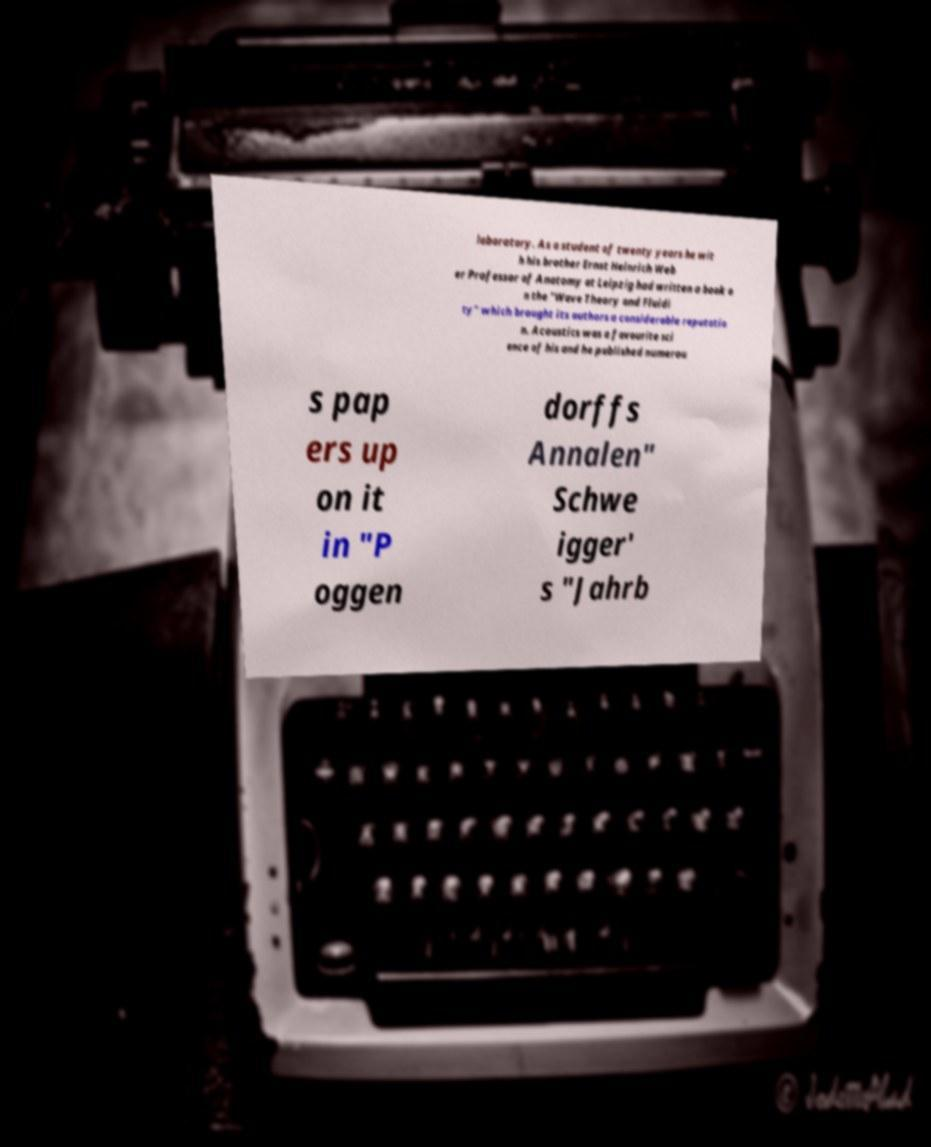Please read and relay the text visible in this image. What does it say? laboratory. As a student of twenty years he wit h his brother Ernst Heinrich Web er Professor of Anatomy at Leipzig had written a book o n the "Wave Theory and Fluidi ty" which brought its authors a considerable reputatio n. Acoustics was a favourite sci ence of his and he published numerou s pap ers up on it in "P oggen dorffs Annalen" Schwe igger' s "Jahrb 